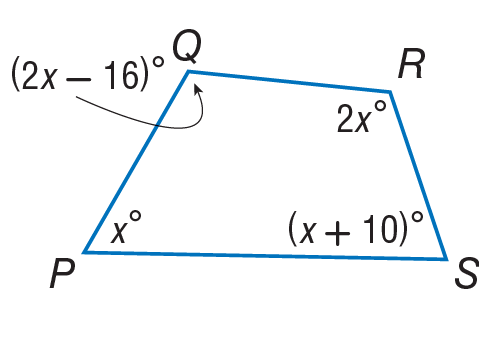Answer the mathemtical geometry problem and directly provide the correct option letter.
Question: Find the measure of \angle S.
Choices: A: 71 B: 128 C: 142 D: 152 A 